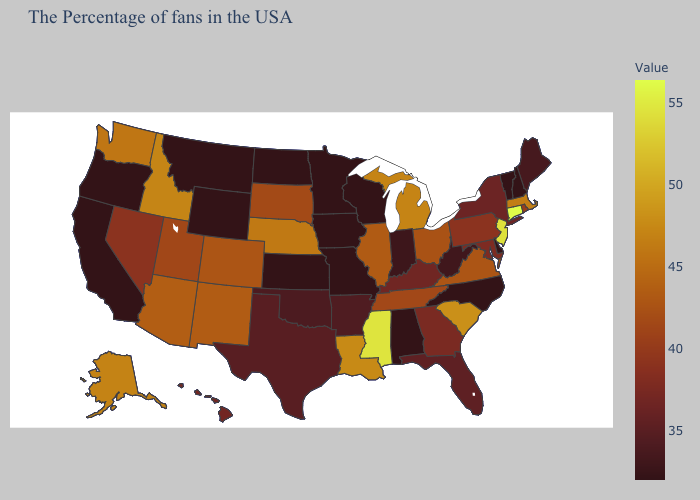Among the states that border Louisiana , which have the highest value?
Write a very short answer. Mississippi. Does California have the lowest value in the West?
Concise answer only. Yes. 